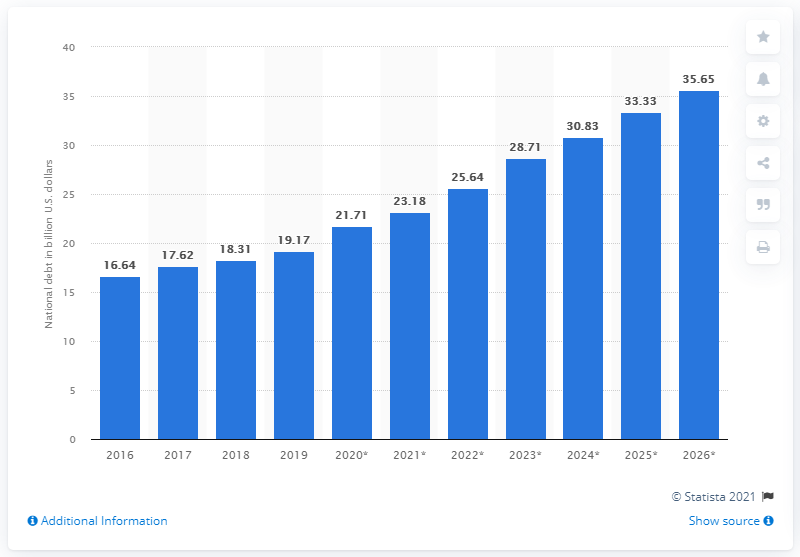Specify some key components in this picture. According to data from 2019, the national debt of El Salvador was approximately 19.17 billion dollars. 